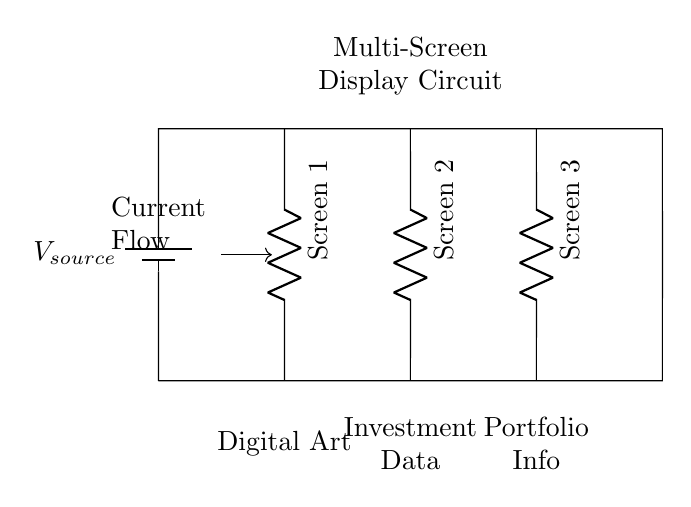What is the type of circuit shown? The circuit is a parallel circuit because all components are connected along the same voltage source, allowing multiple paths for current flow.
Answer: Parallel How many screens are connected? There are three screens connected in the circuit, as indicated by the three resistors labeled Screen 1, Screen 2, and Screen 3.
Answer: Three What does Screen 1 display? Screen 1 displays Digital Art, as described in the circuit diagram below the label for that screen.
Answer: Digital Art What happens to the current in a parallel circuit? In a parallel circuit, the total current is divided among the paths. Each component can operate independently, receiving the full voltage from the source.
Answer: Divided What is the main function of this multi-screen display? The main function of the multi-screen display is to showcase different types of information: Digital Art, Investment Data, and Portfolio Info, respectively.
Answer: Showcasing information If one screen fails, what happens to the others? If one screen fails in a parallel circuit, the other screens continue to operate normally as they are not dependent on each other for current flow.
Answer: Continue to operate 